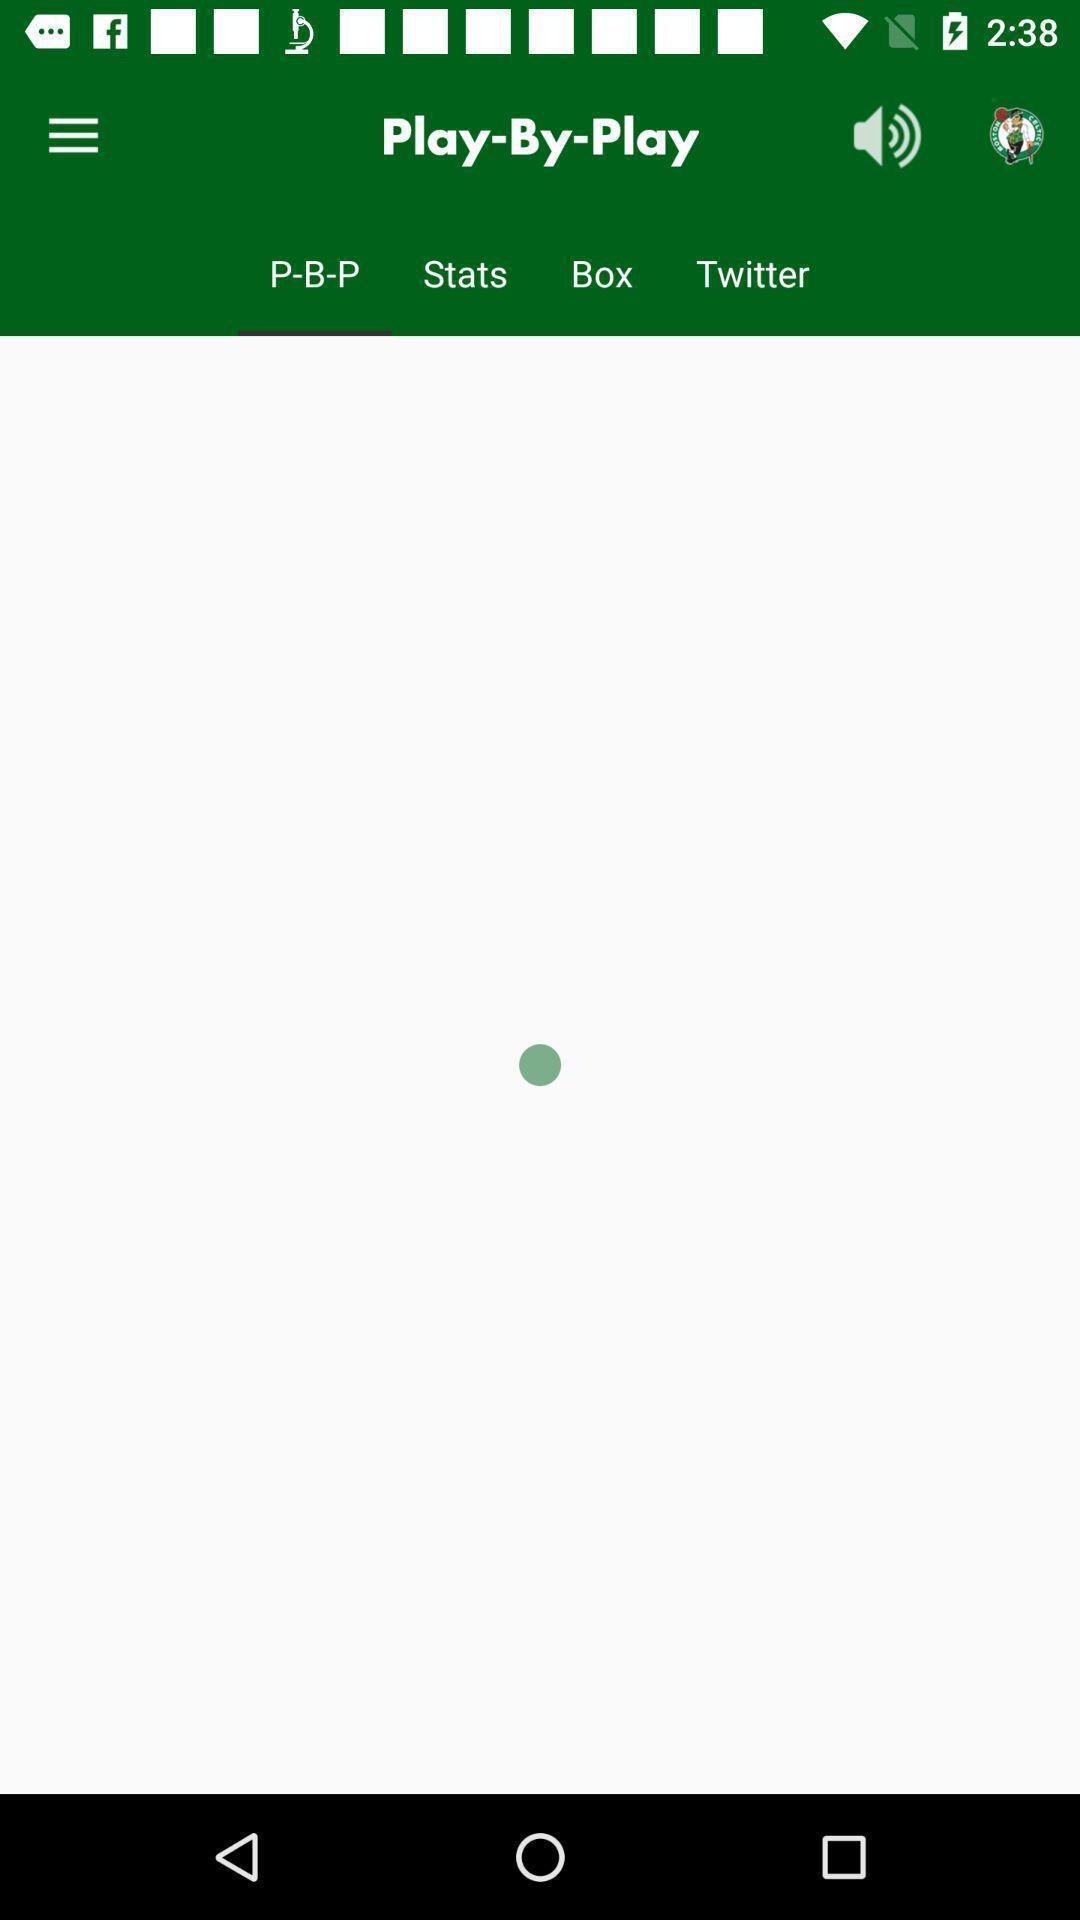Describe the visual elements of this screenshot. Screen page. 